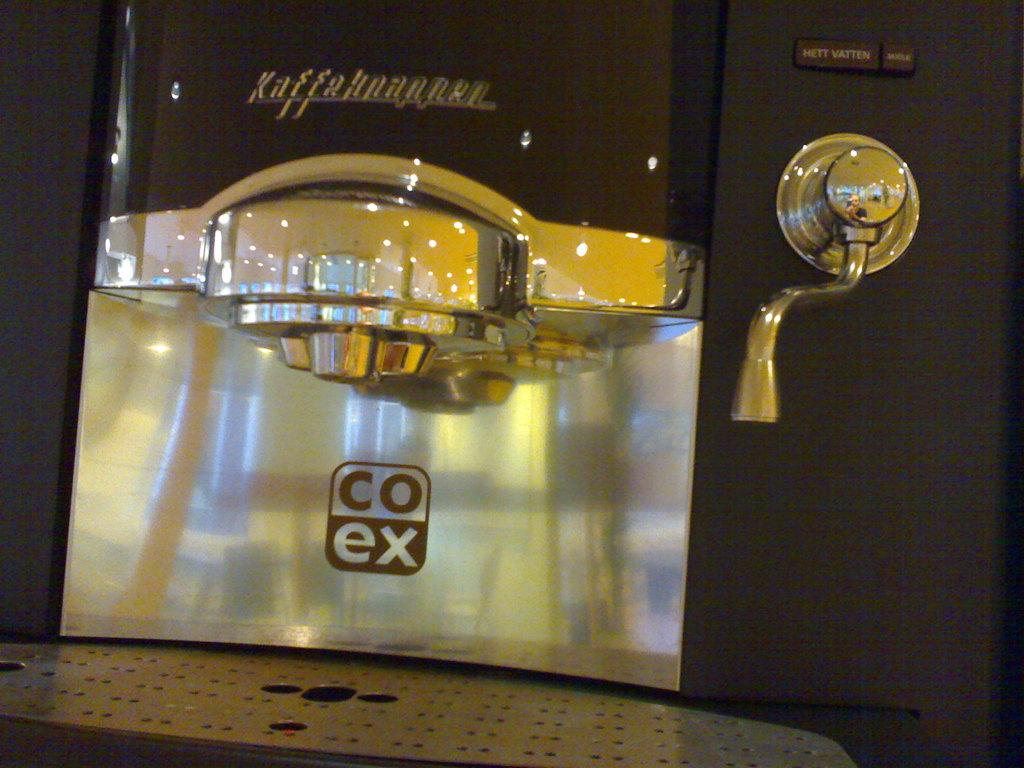<image>
Render a clear and concise summary of the photo. a silver item with co ex on it 